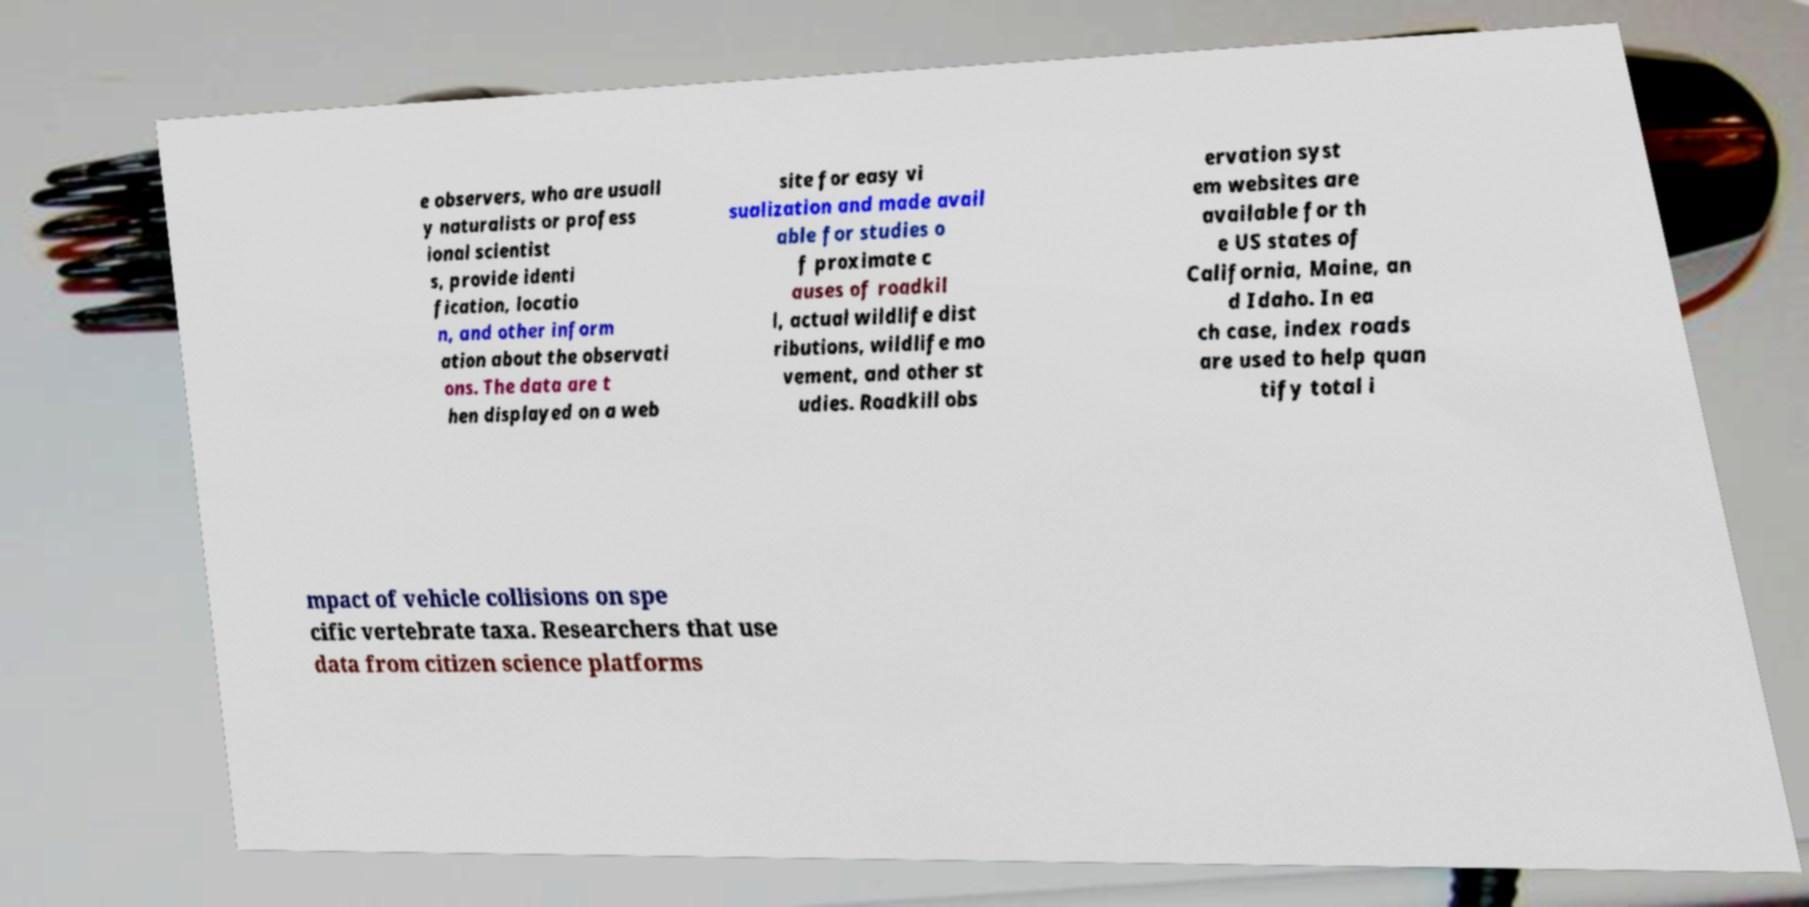Can you read and provide the text displayed in the image?This photo seems to have some interesting text. Can you extract and type it out for me? e observers, who are usuall y naturalists or profess ional scientist s, provide identi fication, locatio n, and other inform ation about the observati ons. The data are t hen displayed on a web site for easy vi sualization and made avail able for studies o f proximate c auses of roadkil l, actual wildlife dist ributions, wildlife mo vement, and other st udies. Roadkill obs ervation syst em websites are available for th e US states of California, Maine, an d Idaho. In ea ch case, index roads are used to help quan tify total i mpact of vehicle collisions on spe cific vertebrate taxa. Researchers that use data from citizen science platforms 